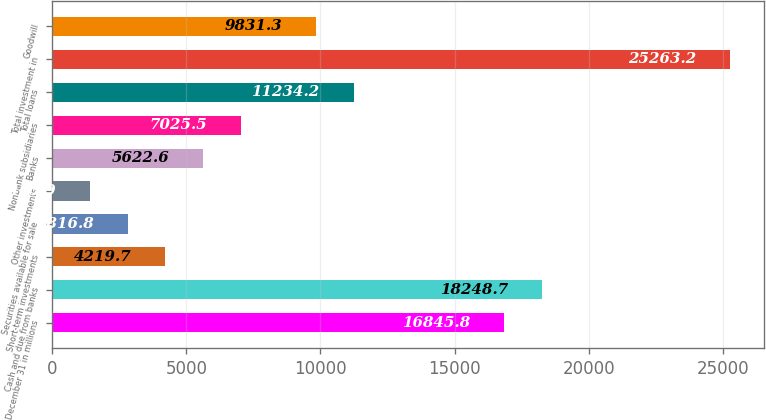Convert chart to OTSL. <chart><loc_0><loc_0><loc_500><loc_500><bar_chart><fcel>December 31 in millions<fcel>Cash and due from banks<fcel>Short-term investments<fcel>Securities available for sale<fcel>Other investments<fcel>Banks<fcel>Nonbank subsidiaries<fcel>Total loans<fcel>Total investment in<fcel>Goodwill<nl><fcel>16845.8<fcel>18248.7<fcel>4219.7<fcel>2816.8<fcel>1413.9<fcel>5622.6<fcel>7025.5<fcel>11234.2<fcel>25263.2<fcel>9831.3<nl></chart> 